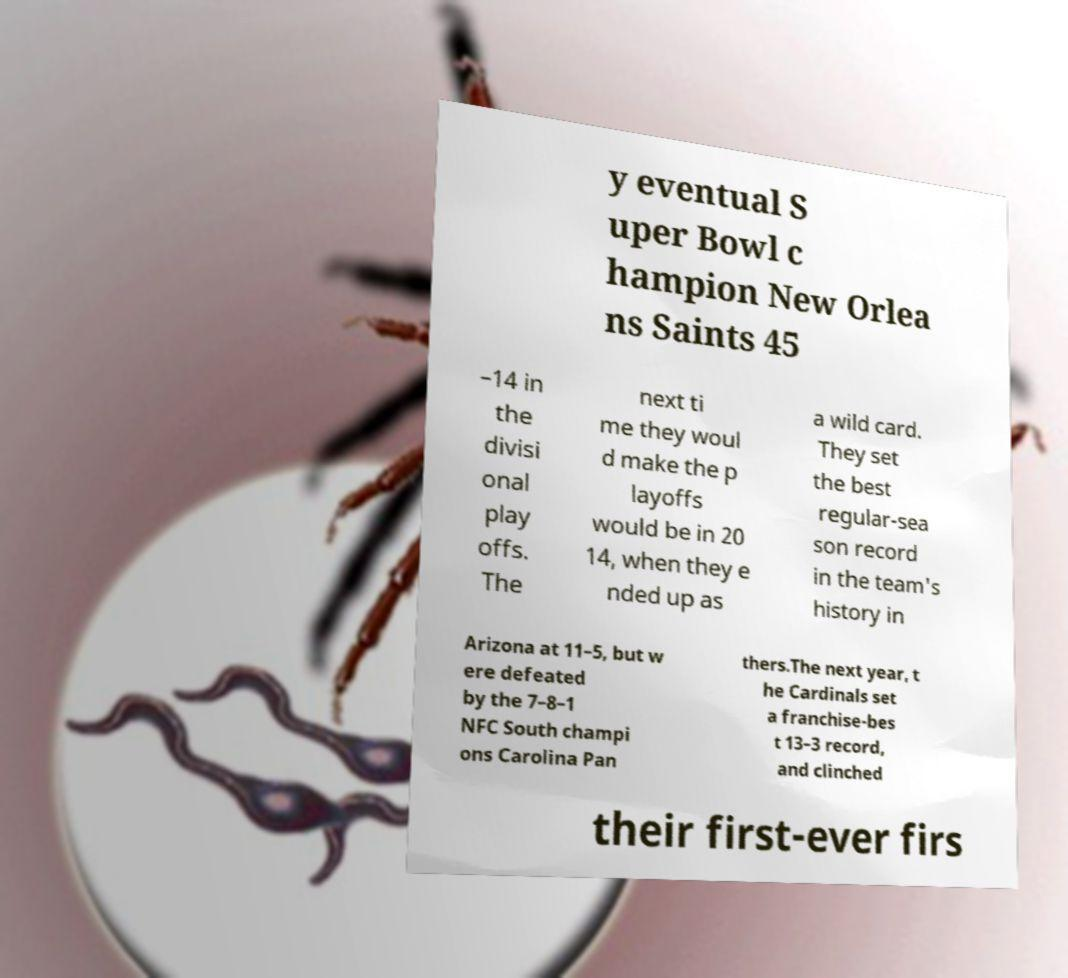Could you extract and type out the text from this image? y eventual S uper Bowl c hampion New Orlea ns Saints 45 –14 in the divisi onal play offs. The next ti me they woul d make the p layoffs would be in 20 14, when they e nded up as a wild card. They set the best regular-sea son record in the team's history in Arizona at 11–5, but w ere defeated by the 7–8–1 NFC South champi ons Carolina Pan thers.The next year, t he Cardinals set a franchise-bes t 13–3 record, and clinched their first-ever firs 